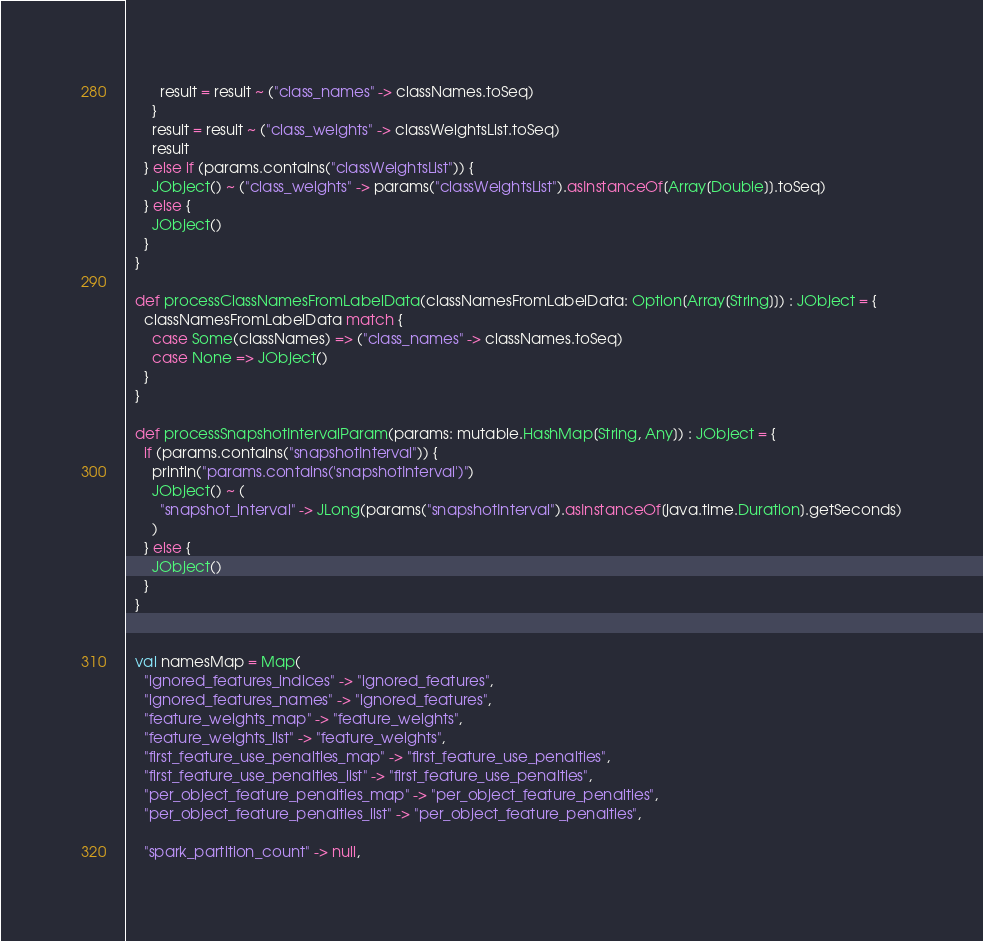<code> <loc_0><loc_0><loc_500><loc_500><_Scala_>        result = result ~ ("class_names" -> classNames.toSeq)
      }
      result = result ~ ("class_weights" -> classWeightsList.toSeq)
      result
    } else if (params.contains("classWeightsList")) {
      JObject() ~ ("class_weights" -> params("classWeightsList").asInstanceOf[Array[Double]].toSeq)
    } else {
      JObject()
    }
  }

  def processClassNamesFromLabelData(classNamesFromLabelData: Option[Array[String]]) : JObject = {
    classNamesFromLabelData match {
      case Some(classNames) => ("class_names" -> classNames.toSeq)
      case None => JObject()
    }
  }

  def processSnapshotIntervalParam(params: mutable.HashMap[String, Any]) : JObject = {
    if (params.contains("snapshotInterval")) {
      println("params.contains('snapshotInterval')")
      JObject() ~ (
        "snapshot_interval" -> JLong(params("snapshotInterval").asInstanceOf[java.time.Duration].getSeconds)
      )
    } else {
      JObject()
    }
  }


  val namesMap = Map(
    "ignored_features_indices" -> "ignored_features",
    "ignored_features_names" -> "ignored_features",
    "feature_weights_map" -> "feature_weights",
    "feature_weights_list" -> "feature_weights",
    "first_feature_use_penalties_map" -> "first_feature_use_penalties",
    "first_feature_use_penalties_list" -> "first_feature_use_penalties",
    "per_object_feature_penalties_map" -> "per_object_feature_penalties",
    "per_object_feature_penalties_list" -> "per_object_feature_penalties",

    "spark_partition_count" -> null,</code> 